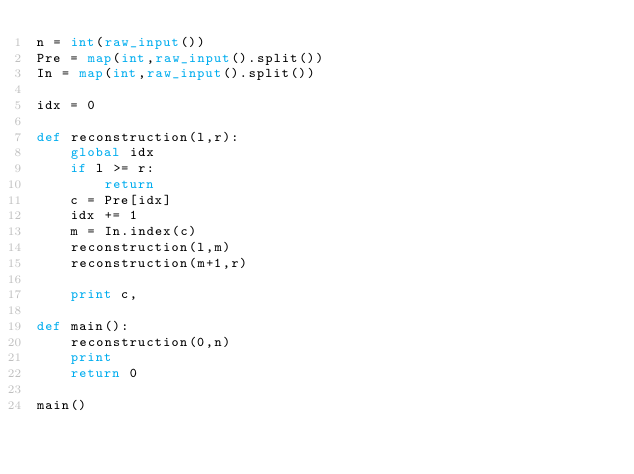Convert code to text. <code><loc_0><loc_0><loc_500><loc_500><_Python_>n = int(raw_input())
Pre = map(int,raw_input().split())
In = map(int,raw_input().split())

idx = 0

def reconstruction(l,r):
    global idx
    if l >= r:
        return
    c = Pre[idx]
    idx += 1
    m = In.index(c)
    reconstruction(l,m)
    reconstruction(m+1,r)

    print c,

def main():
    reconstruction(0,n)
    print 
    return 0

main()</code> 